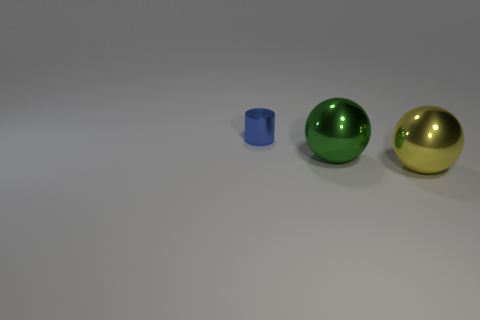Add 1 metal balls. How many objects exist? 4 Subtract all balls. How many objects are left? 1 Add 1 large metal objects. How many large metal objects exist? 3 Subtract 0 cyan balls. How many objects are left? 3 Subtract all yellow metal objects. Subtract all tiny metal cylinders. How many objects are left? 1 Add 2 big yellow shiny spheres. How many big yellow shiny spheres are left? 3 